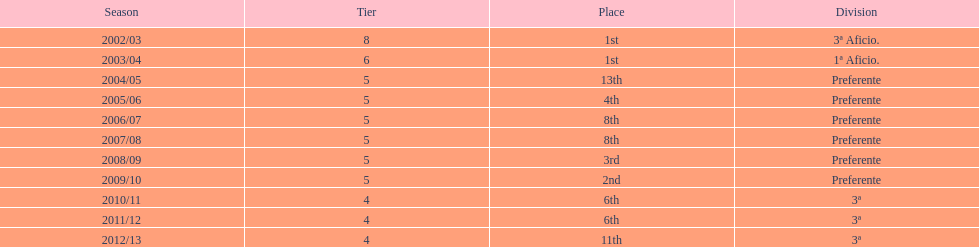How long did the team stay in first place? 2 years. 